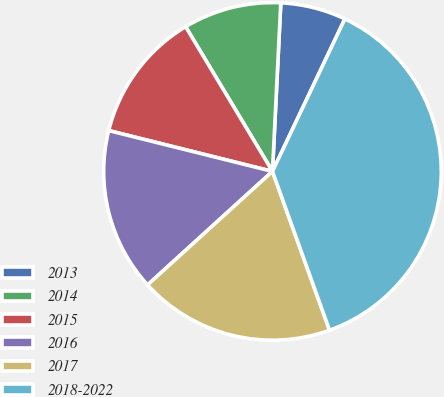Convert chart. <chart><loc_0><loc_0><loc_500><loc_500><pie_chart><fcel>2013<fcel>2014<fcel>2015<fcel>2016<fcel>2017<fcel>2018-2022<nl><fcel>6.27%<fcel>9.39%<fcel>12.51%<fcel>15.63%<fcel>18.75%<fcel>37.46%<nl></chart> 